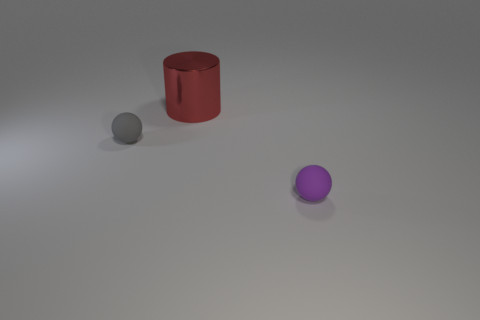Are there any other things that have the same shape as the large red shiny object?
Offer a very short reply. No. Are there any other things that have the same size as the metal cylinder?
Give a very brief answer. No. There is a small ball that is behind the tiny rubber thing in front of the tiny gray rubber object; what is its material?
Provide a short and direct response. Rubber. Are there fewer purple things on the left side of the purple thing than big gray shiny things?
Your response must be concise. No. The small thing to the right of the red object has what shape?
Give a very brief answer. Sphere. There is a gray matte ball; does it have the same size as the matte sphere right of the red thing?
Your answer should be compact. Yes. Is there a purple thing made of the same material as the small gray sphere?
Make the answer very short. Yes. How many cylinders are red objects or large green objects?
Offer a terse response. 1. There is a large red cylinder behind the tiny purple matte sphere; is there a small matte sphere that is right of it?
Keep it short and to the point. Yes. Are there fewer metallic cylinders than large green matte cylinders?
Your response must be concise. No. 